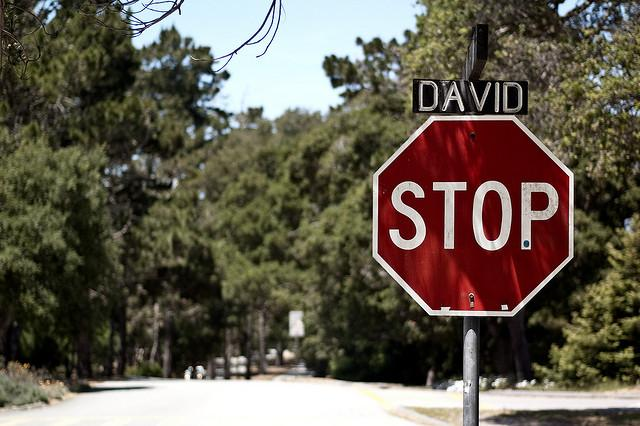What is the name of the street parallel to the stop sign? david 